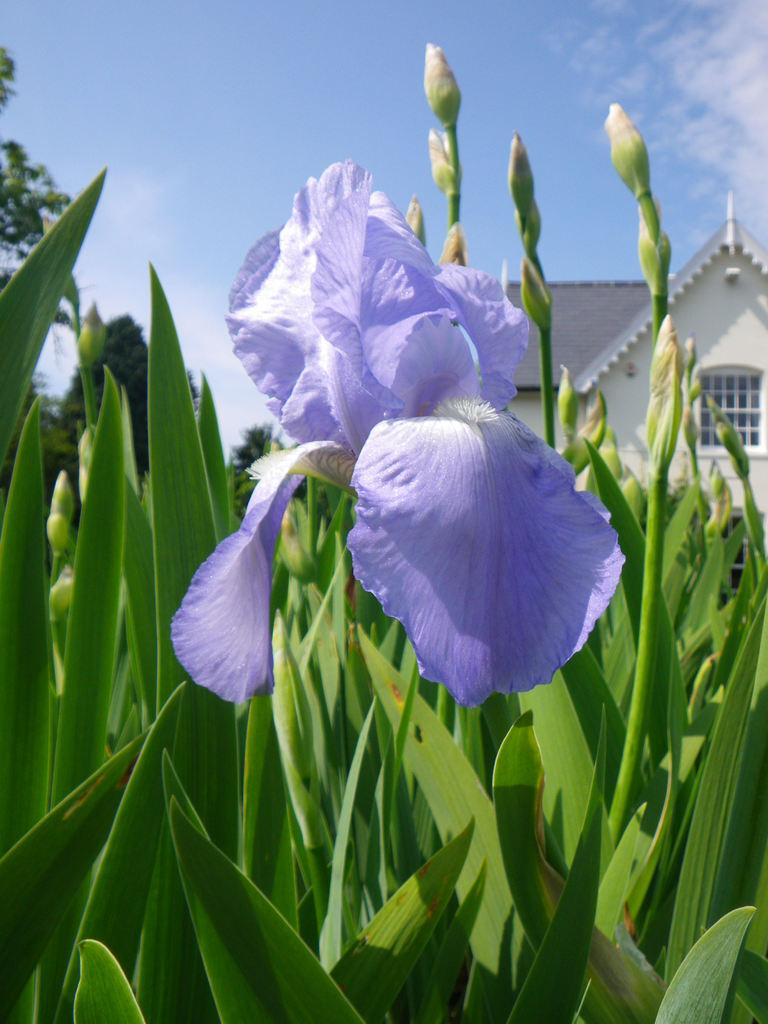What type of living organisms can be seen in the image? Plants can be seen in the image. Can you describe any specific features of the plants? There is a flower on one of the plants. What is visible in the background of the image? There is a house in the background of the image. What type of apple is being picked by the partner in the image? There is no partner or apple present in the image; it features plants and a flower. 